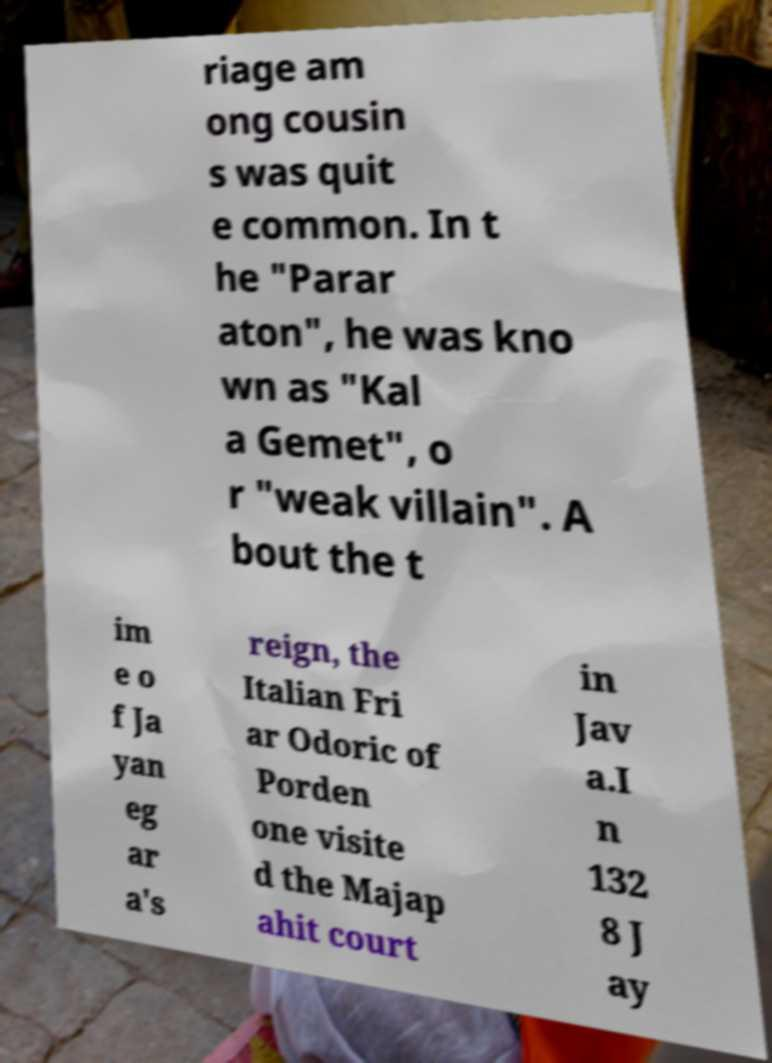Please read and relay the text visible in this image. What does it say? riage am ong cousin s was quit e common. In t he "Parar aton", he was kno wn as "Kal a Gemet", o r "weak villain". A bout the t im e o f Ja yan eg ar a's reign, the Italian Fri ar Odoric of Porden one visite d the Majap ahit court in Jav a.I n 132 8 J ay 